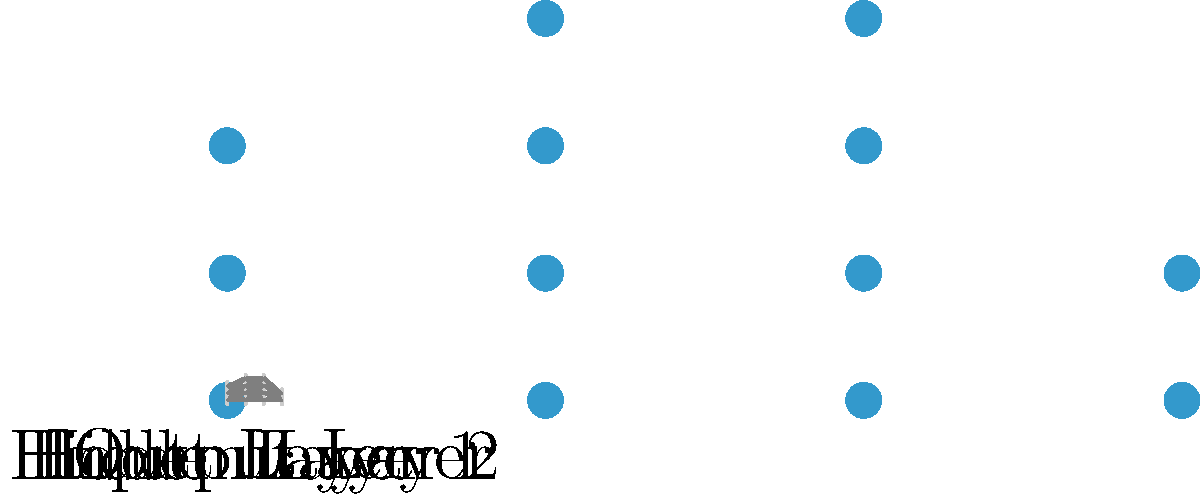As a creative writer helping a doctoral candidate explain neural network architecture, how would you describe the flow of information through the layers in this simplified diagram, and what is the significance of the interconnected nodes? To explain the flow of information through the layers in a neural network:

1. Input Layer: This is where the raw data enters the network. Each node in this layer represents a feature of the input data.

2. Hidden Layers: These layers process the information. In our diagram, we have two hidden layers:
   a. Hidden Layer 1: Receives inputs from the input layer and performs initial transformations.
   b. Hidden Layer 2: Further processes the information from Hidden Layer 1.

3. Output Layer: This layer provides the final result or prediction of the network.

The flow of information:
- Data enters through the input layer.
- Each node in a layer is connected to every node in the subsequent layer.
- Information travels along these connections, represented by arrows in the diagram.
- At each node, the incoming information is processed using weights and activation functions.
- The processed information is then passed to the next layer.
- This continues until the output layer is reached, where the final result is produced.

Significance of interconnected nodes:
1. Learning capability: The connections between nodes allow the network to learn complex patterns.
2. Flexibility: The network can adjust the strength of connections (weights) to improve its performance.
3. Non-linearity: Multiple layers of interconnected nodes enable the network to model non-linear relationships in data.
4. Feature hierarchy: Each layer can learn increasingly abstract features of the data.
5. Parallelism: Multiple nodes in each layer allow for parallel processing of information.

In simplifying this for a research paper, you might describe it as a system of interconnected "information processors" that work together to transform input data into meaningful output, learning and adapting as they process more information.
Answer: Information flows from input to output through interconnected layers, with each node processing and passing data to the next layer, enabling learning and pattern recognition. 